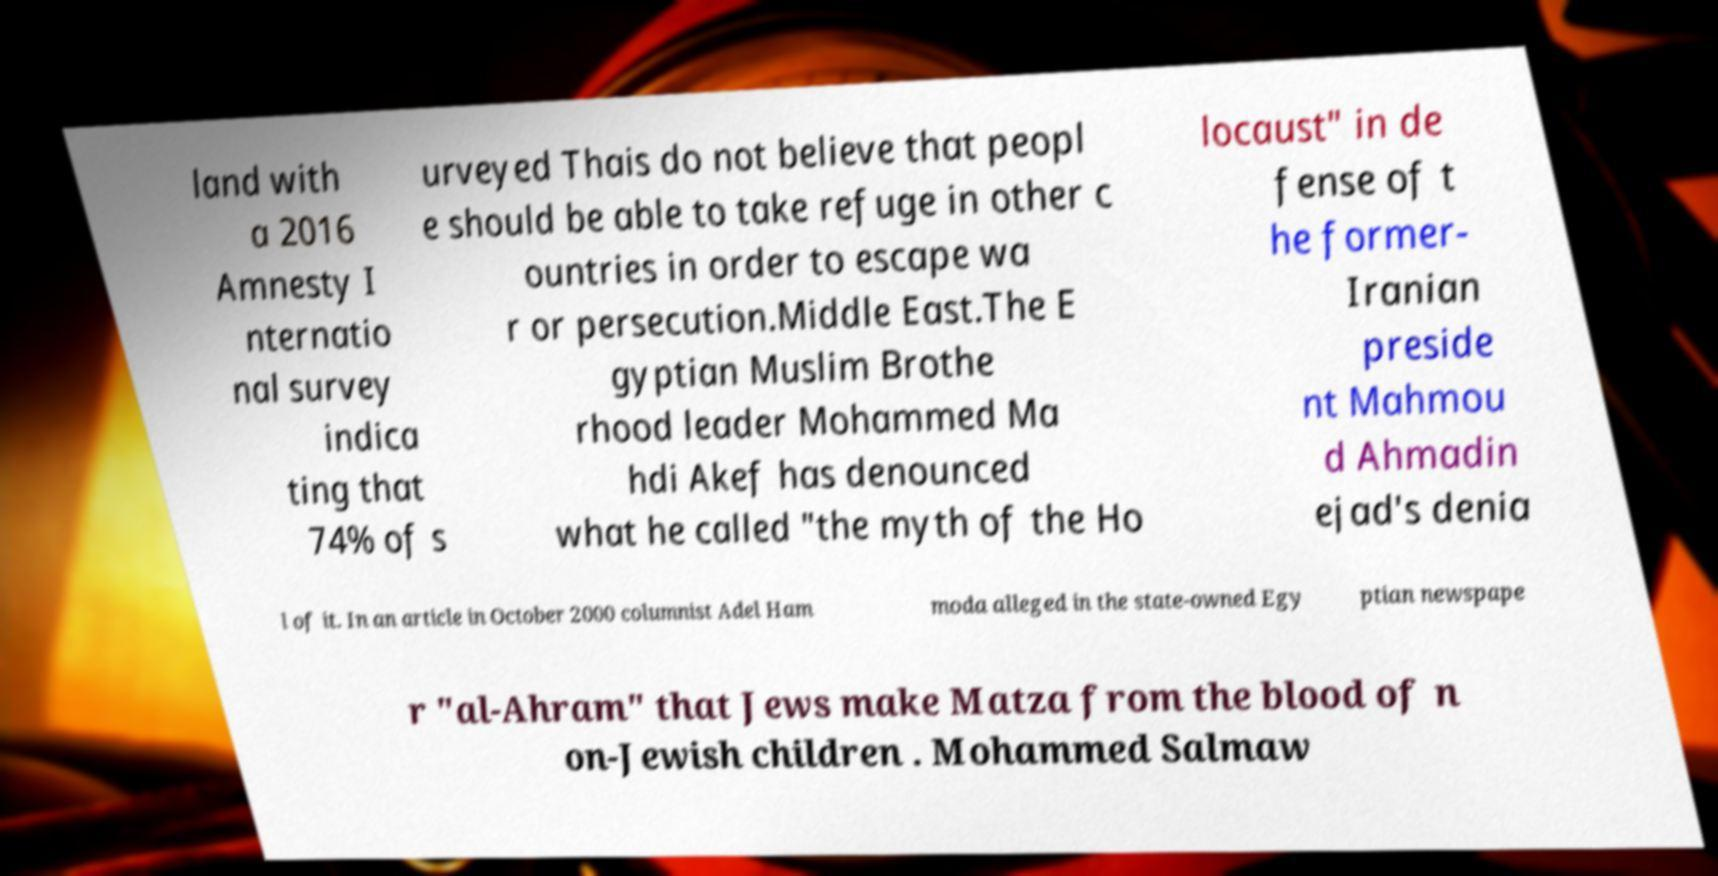Could you extract and type out the text from this image? land with a 2016 Amnesty I nternatio nal survey indica ting that 74% of s urveyed Thais do not believe that peopl e should be able to take refuge in other c ountries in order to escape wa r or persecution.Middle East.The E gyptian Muslim Brothe rhood leader Mohammed Ma hdi Akef has denounced what he called "the myth of the Ho locaust" in de fense of t he former- Iranian preside nt Mahmou d Ahmadin ejad's denia l of it. In an article in October 2000 columnist Adel Ham moda alleged in the state-owned Egy ptian newspape r "al-Ahram" that Jews make Matza from the blood of n on-Jewish children . Mohammed Salmaw 